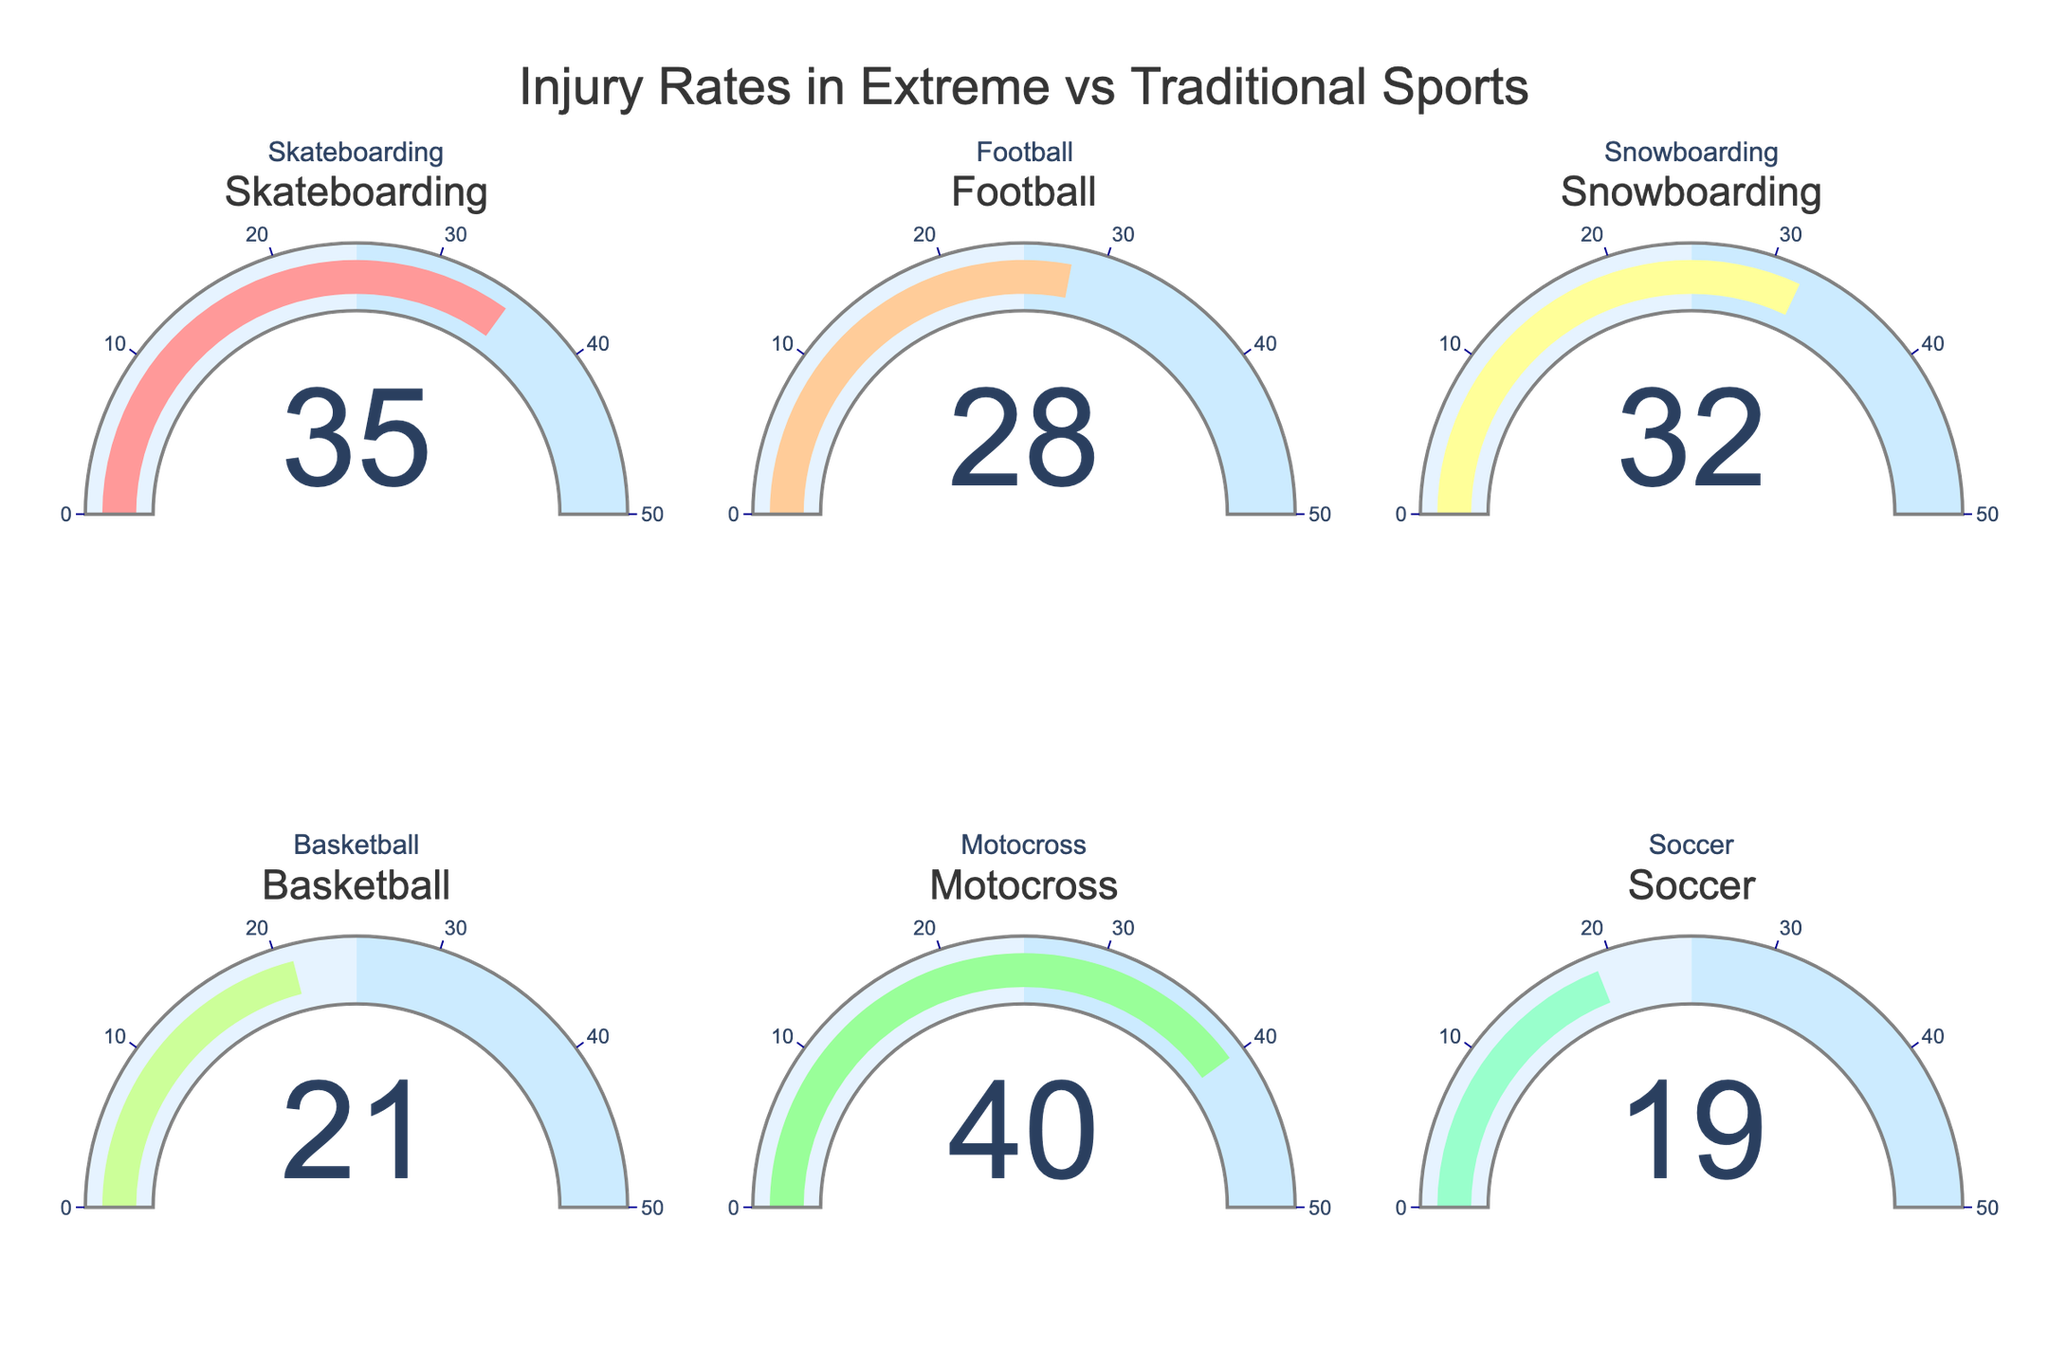which sport has the highest injury rate? First, scan all the gauge charts for the injury rates. Identify the sport with the highest value displayed.
Answer: Motocross what is the injury rate for snowboarding? Look for the gauge chart with the 'Snowboarding' title and read the number displayed.
Answer: 32 how many extreme sports are shown in the figure? Identify which of the sports listed in the subplots are considered extreme sports: Skateboarding, Snowboarding, and Motocross. Count these sports.
Answer: 3 what is the difference between the injury rates of skateboarding and basketball? Find the values for both Skateboarding (35) and Basketball (21). Calculate the difference: 35 - 21.
Answer: 14 does any traditional sport have a higher injury rate than any extreme sport? Compare the injury rates of traditional sports (Football, Basketball, Soccer) with those of extreme sports (Skateboarding, Snowboarding, Motocross). Notice that Football (28) is less than Skateboarding (35), Snowboarding (32), and Motocross (40); Basketball (21) and Soccer (19) are also less than these extreme sports. Therefore, no traditional sport has a higher injury rate than any extreme sport.
Answer: No what is the average injury rate for traditional sports? Identify the injury rates for traditional sports: Football (28), Basketball (21), and Soccer (19). Sum them up: 28 + 21 + 19 = 68. Calculate the average by dividing by 3: 68 / 3 ≈ 22.67.
Answer: Approximately 22.67 are there any sports with an injury rate below 20? Scan the gauge charts to identify any sport with a rate below 20. Soccer has an injury rate of 19.
Answer: Yes, Soccer what is the combined injury rate for all the extreme sports? Identify the injury rates for the extreme sports: Skateboarding (35), Snowboarding (32), and Motocross (40). Sum them up: 35 + 32 + 40.
Answer: 107 which sport has the lowest injury rate? Scan all the gauge charts for the injury rates. Identify the sport with the lowest value displayed (Soccer, with 19).
Answer: Soccer compare the injury rates of football and soccer. which one is higher? Look at the gauge charts for Football (28) and Soccer (19). Compare the values to see that Football has the higher rate.
Answer: Football 